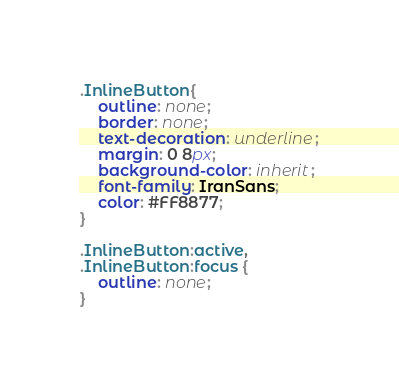<code> <loc_0><loc_0><loc_500><loc_500><_CSS_>.InlineButton{
    outline: none;
    border: none;
    text-decoration: underline;
    margin: 0 8px;
    background-color: inherit;
    font-family: IranSans;
    color: #FF8877;
}

.InlineButton:active,
.InlineButton:focus {
    outline: none;
}</code> 